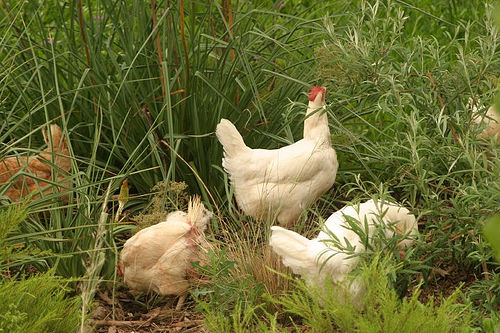<image>
Is the chicken behind the plant? No. The chicken is not behind the plant. From this viewpoint, the chicken appears to be positioned elsewhere in the scene. 